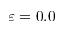Convert formula to latex. <formula><loc_0><loc_0><loc_500><loc_500>\varepsilon = 0 . 0</formula> 